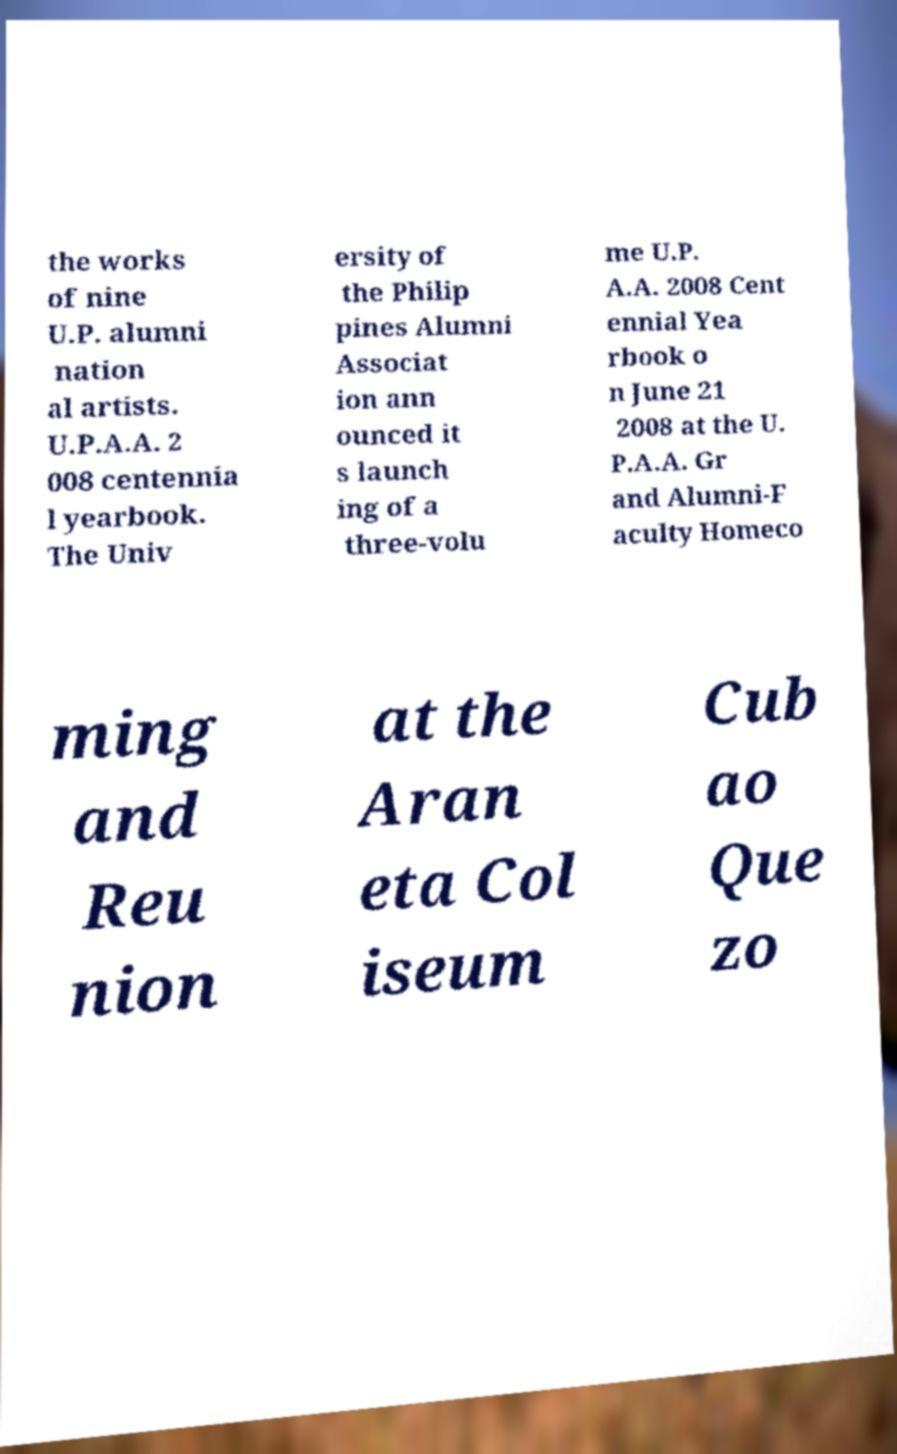Could you extract and type out the text from this image? the works of nine U.P. alumni nation al artists. U.P.A.A. 2 008 centennia l yearbook. The Univ ersity of the Philip pines Alumni Associat ion ann ounced it s launch ing of a three-volu me U.P. A.A. 2008 Cent ennial Yea rbook o n June 21 2008 at the U. P.A.A. Gr and Alumni-F aculty Homeco ming and Reu nion at the Aran eta Col iseum Cub ao Que zo 